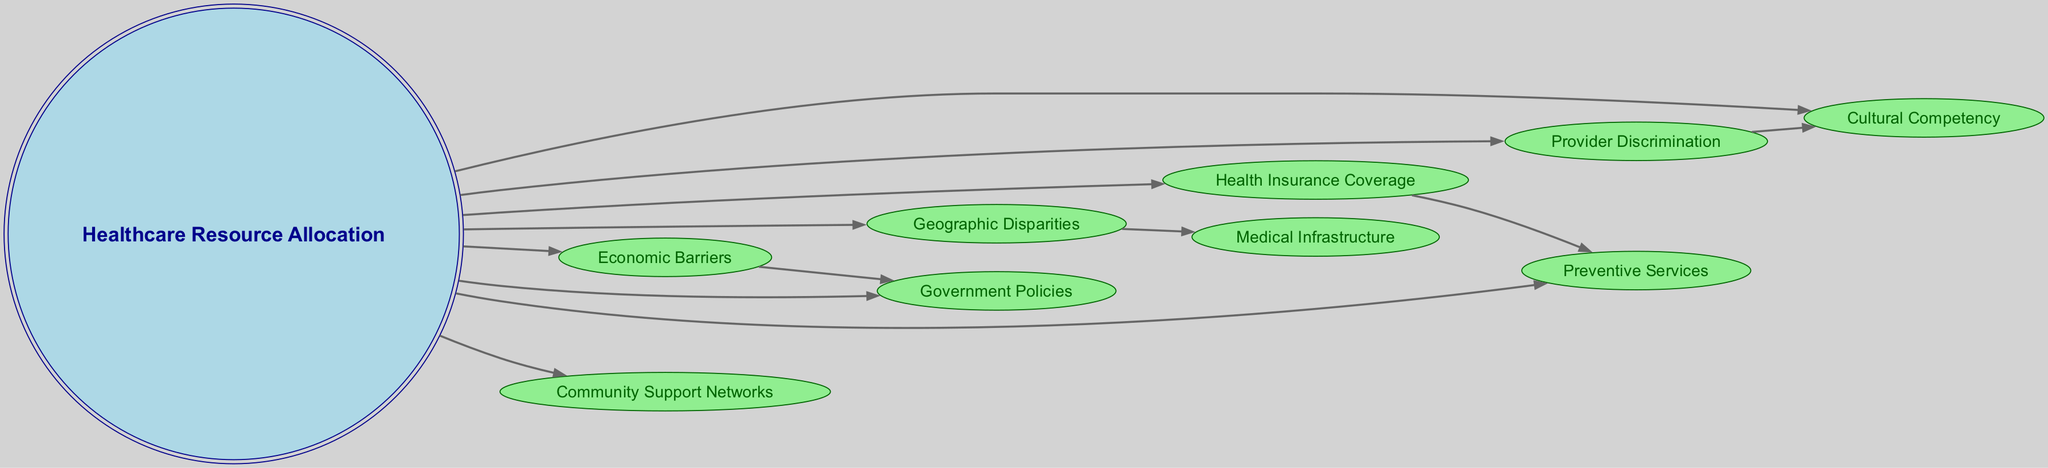What is the central theme of the diagram? The center node clearly indicates that the diagram focuses on "Healthcare Resource Allocation," which is the main subject covered.
Answer: Healthcare Resource Allocation How many nodes are represented in the diagram? By counting all individual nodes, including the central node and the peripheral nodes, we find there are 9 nodes in total.
Answer: 9 Which node describes biases in treatment? The node labeled "Provider Discrimination" highlights the presence of biases in the provision of treatments and services, making it the relevant descriptor.
Answer: Provider Discrimination What is connected to "Geographic Disparities"? The diagram indicates that "Medical Infrastructure" is directly connected to "Geographic Disparities," implying that resource availability can be affected by geographic factors.
Answer: Medical Infrastructure What factors contribute to "Healthcare Resource Allocation"? Several nodes connect to "Healthcare Resource Allocation," including "Economic Barriers," "Geographic Disparities," "Health Insurance Coverage," "Provider Discrimination," "Preventive Services," "Government Policies," "Cultural Competency," and "Community Support Networks," indicating multiple contributing factors.
Answer: Economic Barriers, Geographic Disparities, Health Insurance Coverage, Provider Discrimination, Preventive Services, Government Policies, Cultural Competency, Community Support Networks How does "Health Insurance Coverage" relate to other nodes? "Health Insurance Coverage" is shown as connected to "Preventive Services," indicating that the level of insurance coverage impacts access to preventive healthcare services.
Answer: Preventive Services Which node emphasizes the role of local organizations? The "Community Support Networks" node is highlighted to represent the importance and role of local organizations and support groups in healthcare resource allocation.
Answer: Community Support Networks How many edges connect to "Provider Discrimination"? The node "Provider Discrimination" is connected to two edges: one to "Healthcare Resource Allocation" and another to "Cultural Competency," totaling two edges.
Answer: 2 What do "Economic Barriers" influence in the diagram? "Economic Barriers" connects to "Healthcare Resource Allocation" and also influences "Government Policies," indicating that financial disadvantages impact overall resource distribution and policy effectiveness.
Answer: Government Policies What aspect does "Cultural Competency" address? The node "Cultural Competency" addresses the understanding of healthcare providers relating to cultural differences, which is essential for equitable care delivery.
Answer: Understanding of cultural differences 